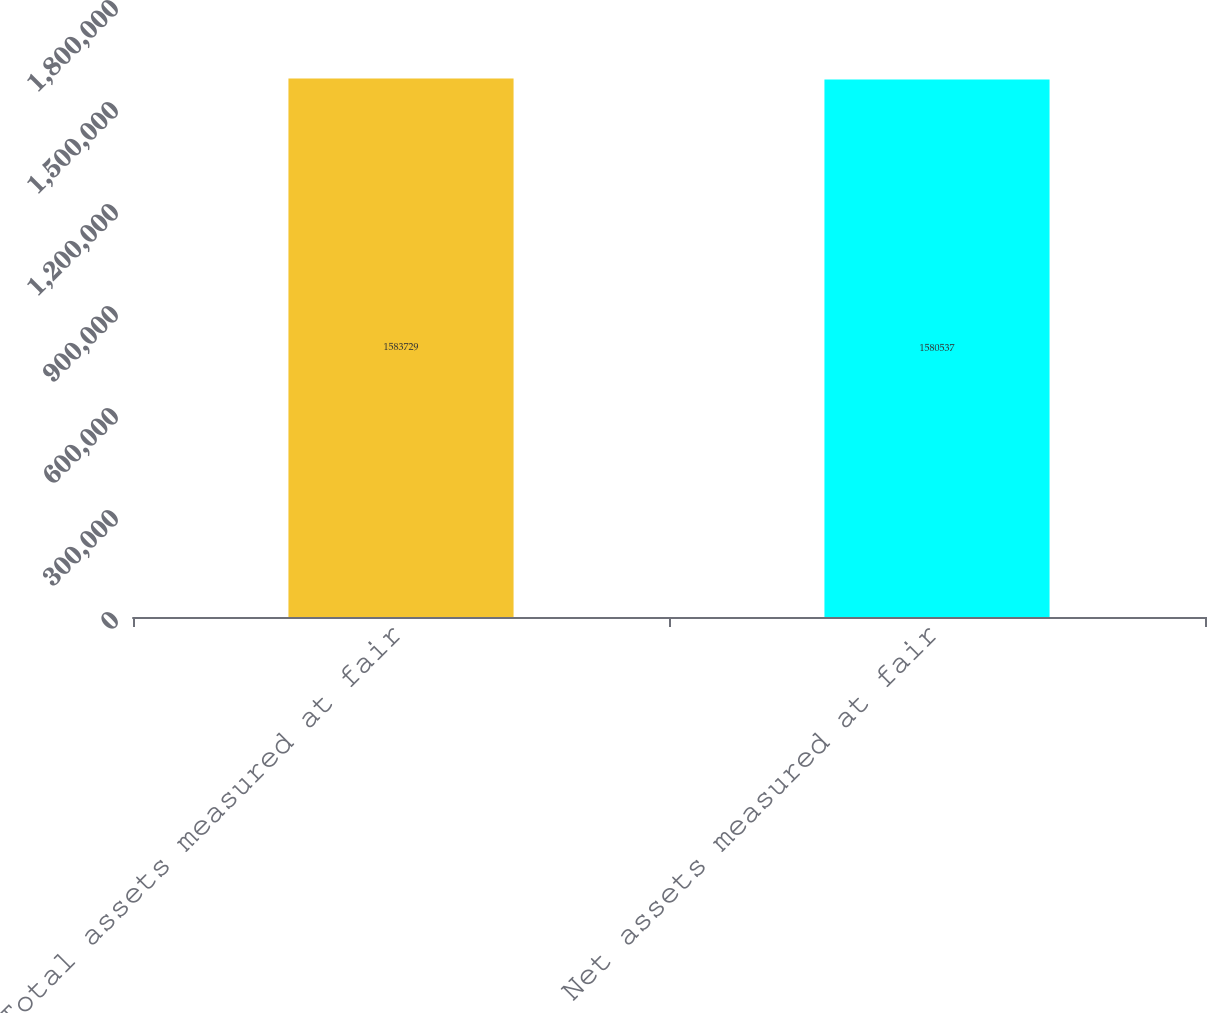<chart> <loc_0><loc_0><loc_500><loc_500><bar_chart><fcel>Total assets measured at fair<fcel>Net assets measured at fair<nl><fcel>1.58373e+06<fcel>1.58054e+06<nl></chart> 